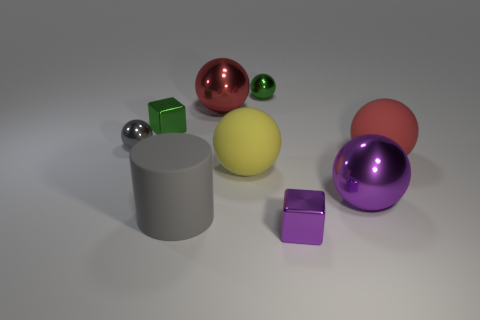Subtract all large balls. How many balls are left? 2 Subtract all cubes. How many objects are left? 7 Add 1 small blocks. How many objects exist? 10 Subtract all gray spheres. How many spheres are left? 5 Subtract 1 cylinders. How many cylinders are left? 0 Add 8 big gray objects. How many big gray objects exist? 9 Subtract 1 gray cylinders. How many objects are left? 8 Subtract all yellow cylinders. Subtract all cyan blocks. How many cylinders are left? 1 Subtract all brown cubes. How many green balls are left? 1 Subtract all cyan rubber things. Subtract all large purple spheres. How many objects are left? 8 